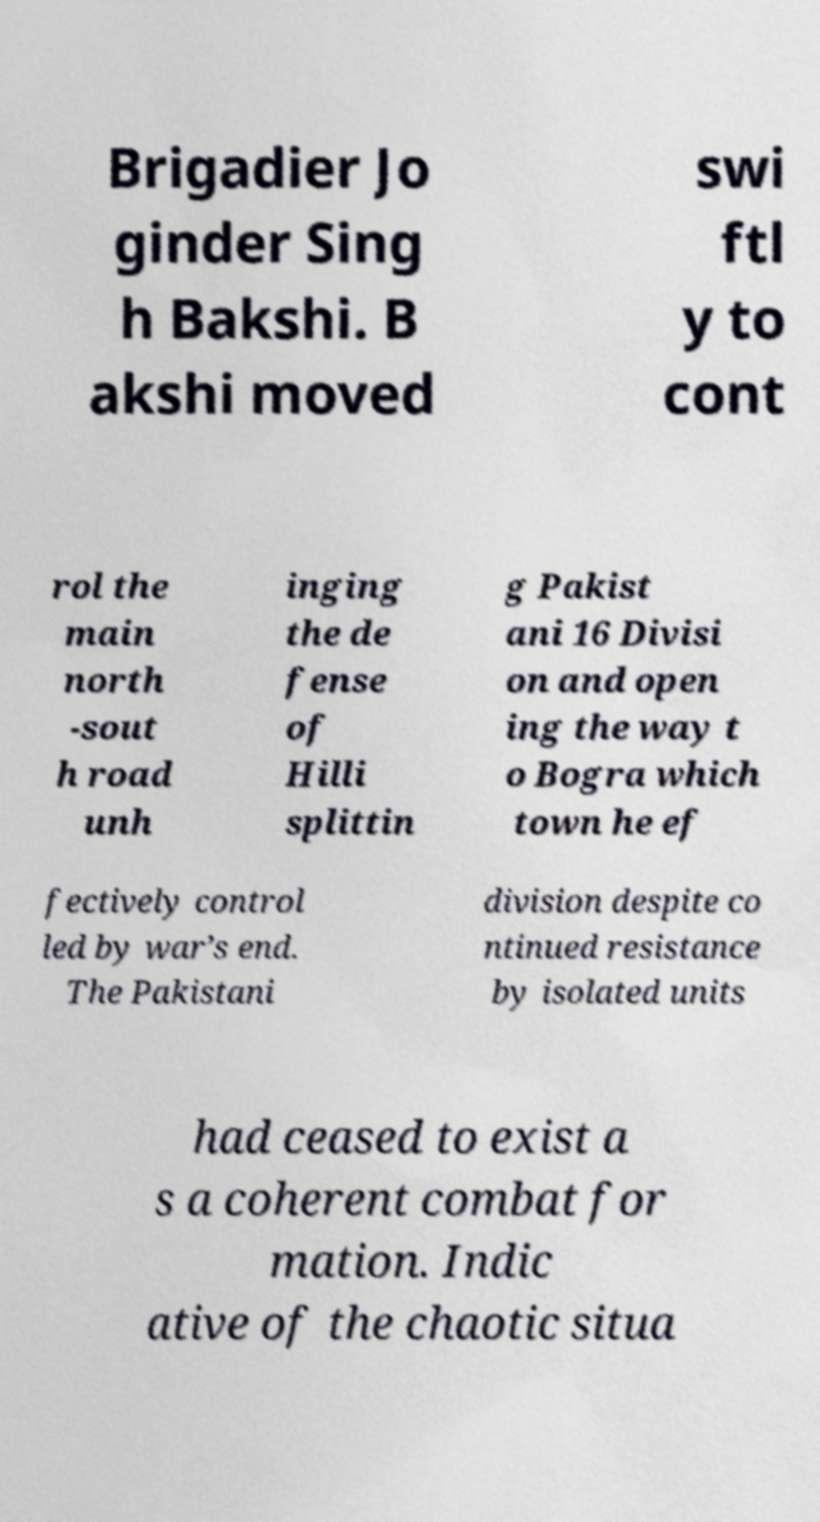Can you read and provide the text displayed in the image?This photo seems to have some interesting text. Can you extract and type it out for me? Brigadier Jo ginder Sing h Bakshi. B akshi moved swi ftl y to cont rol the main north -sout h road unh inging the de fense of Hilli splittin g Pakist ani 16 Divisi on and open ing the way t o Bogra which town he ef fectively control led by war’s end. The Pakistani division despite co ntinued resistance by isolated units had ceased to exist a s a coherent combat for mation. Indic ative of the chaotic situa 